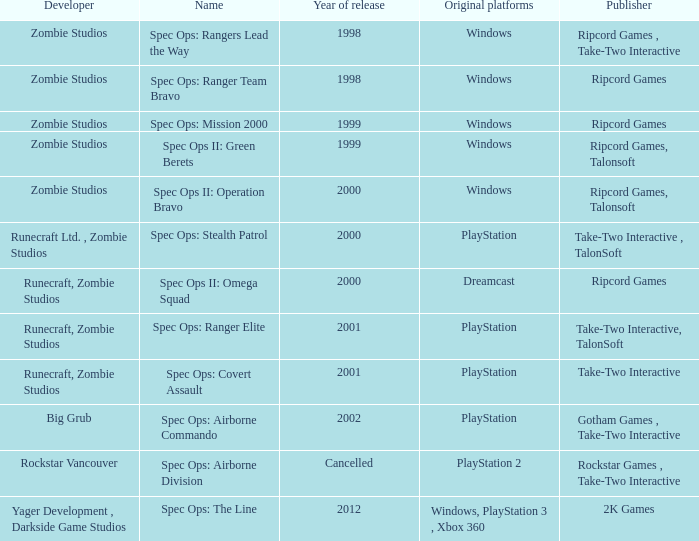Which publisher has release year of 2000 and an original dreamcast platform? Ripcord Games. 